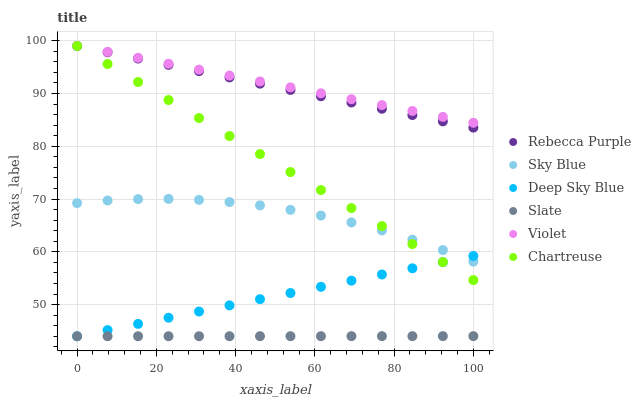Does Slate have the minimum area under the curve?
Answer yes or no. Yes. Does Violet have the maximum area under the curve?
Answer yes or no. Yes. Does Chartreuse have the minimum area under the curve?
Answer yes or no. No. Does Chartreuse have the maximum area under the curve?
Answer yes or no. No. Is Deep Sky Blue the smoothest?
Answer yes or no. Yes. Is Sky Blue the roughest?
Answer yes or no. Yes. Is Chartreuse the smoothest?
Answer yes or no. No. Is Chartreuse the roughest?
Answer yes or no. No. Does Slate have the lowest value?
Answer yes or no. Yes. Does Chartreuse have the lowest value?
Answer yes or no. No. Does Violet have the highest value?
Answer yes or no. Yes. Does Deep Sky Blue have the highest value?
Answer yes or no. No. Is Sky Blue less than Rebecca Purple?
Answer yes or no. Yes. Is Violet greater than Sky Blue?
Answer yes or no. Yes. Does Deep Sky Blue intersect Sky Blue?
Answer yes or no. Yes. Is Deep Sky Blue less than Sky Blue?
Answer yes or no. No. Is Deep Sky Blue greater than Sky Blue?
Answer yes or no. No. Does Sky Blue intersect Rebecca Purple?
Answer yes or no. No. 